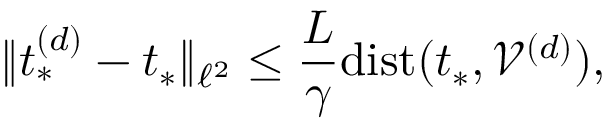<formula> <loc_0><loc_0><loc_500><loc_500>\| t _ { * } ^ { ( d ) } - t _ { * } \| _ { \ell ^ { 2 } } \leq \frac { L } { \gamma } d i s t ( t _ { * } , \mathcal { V } ^ { ( d ) } ) ,</formula> 